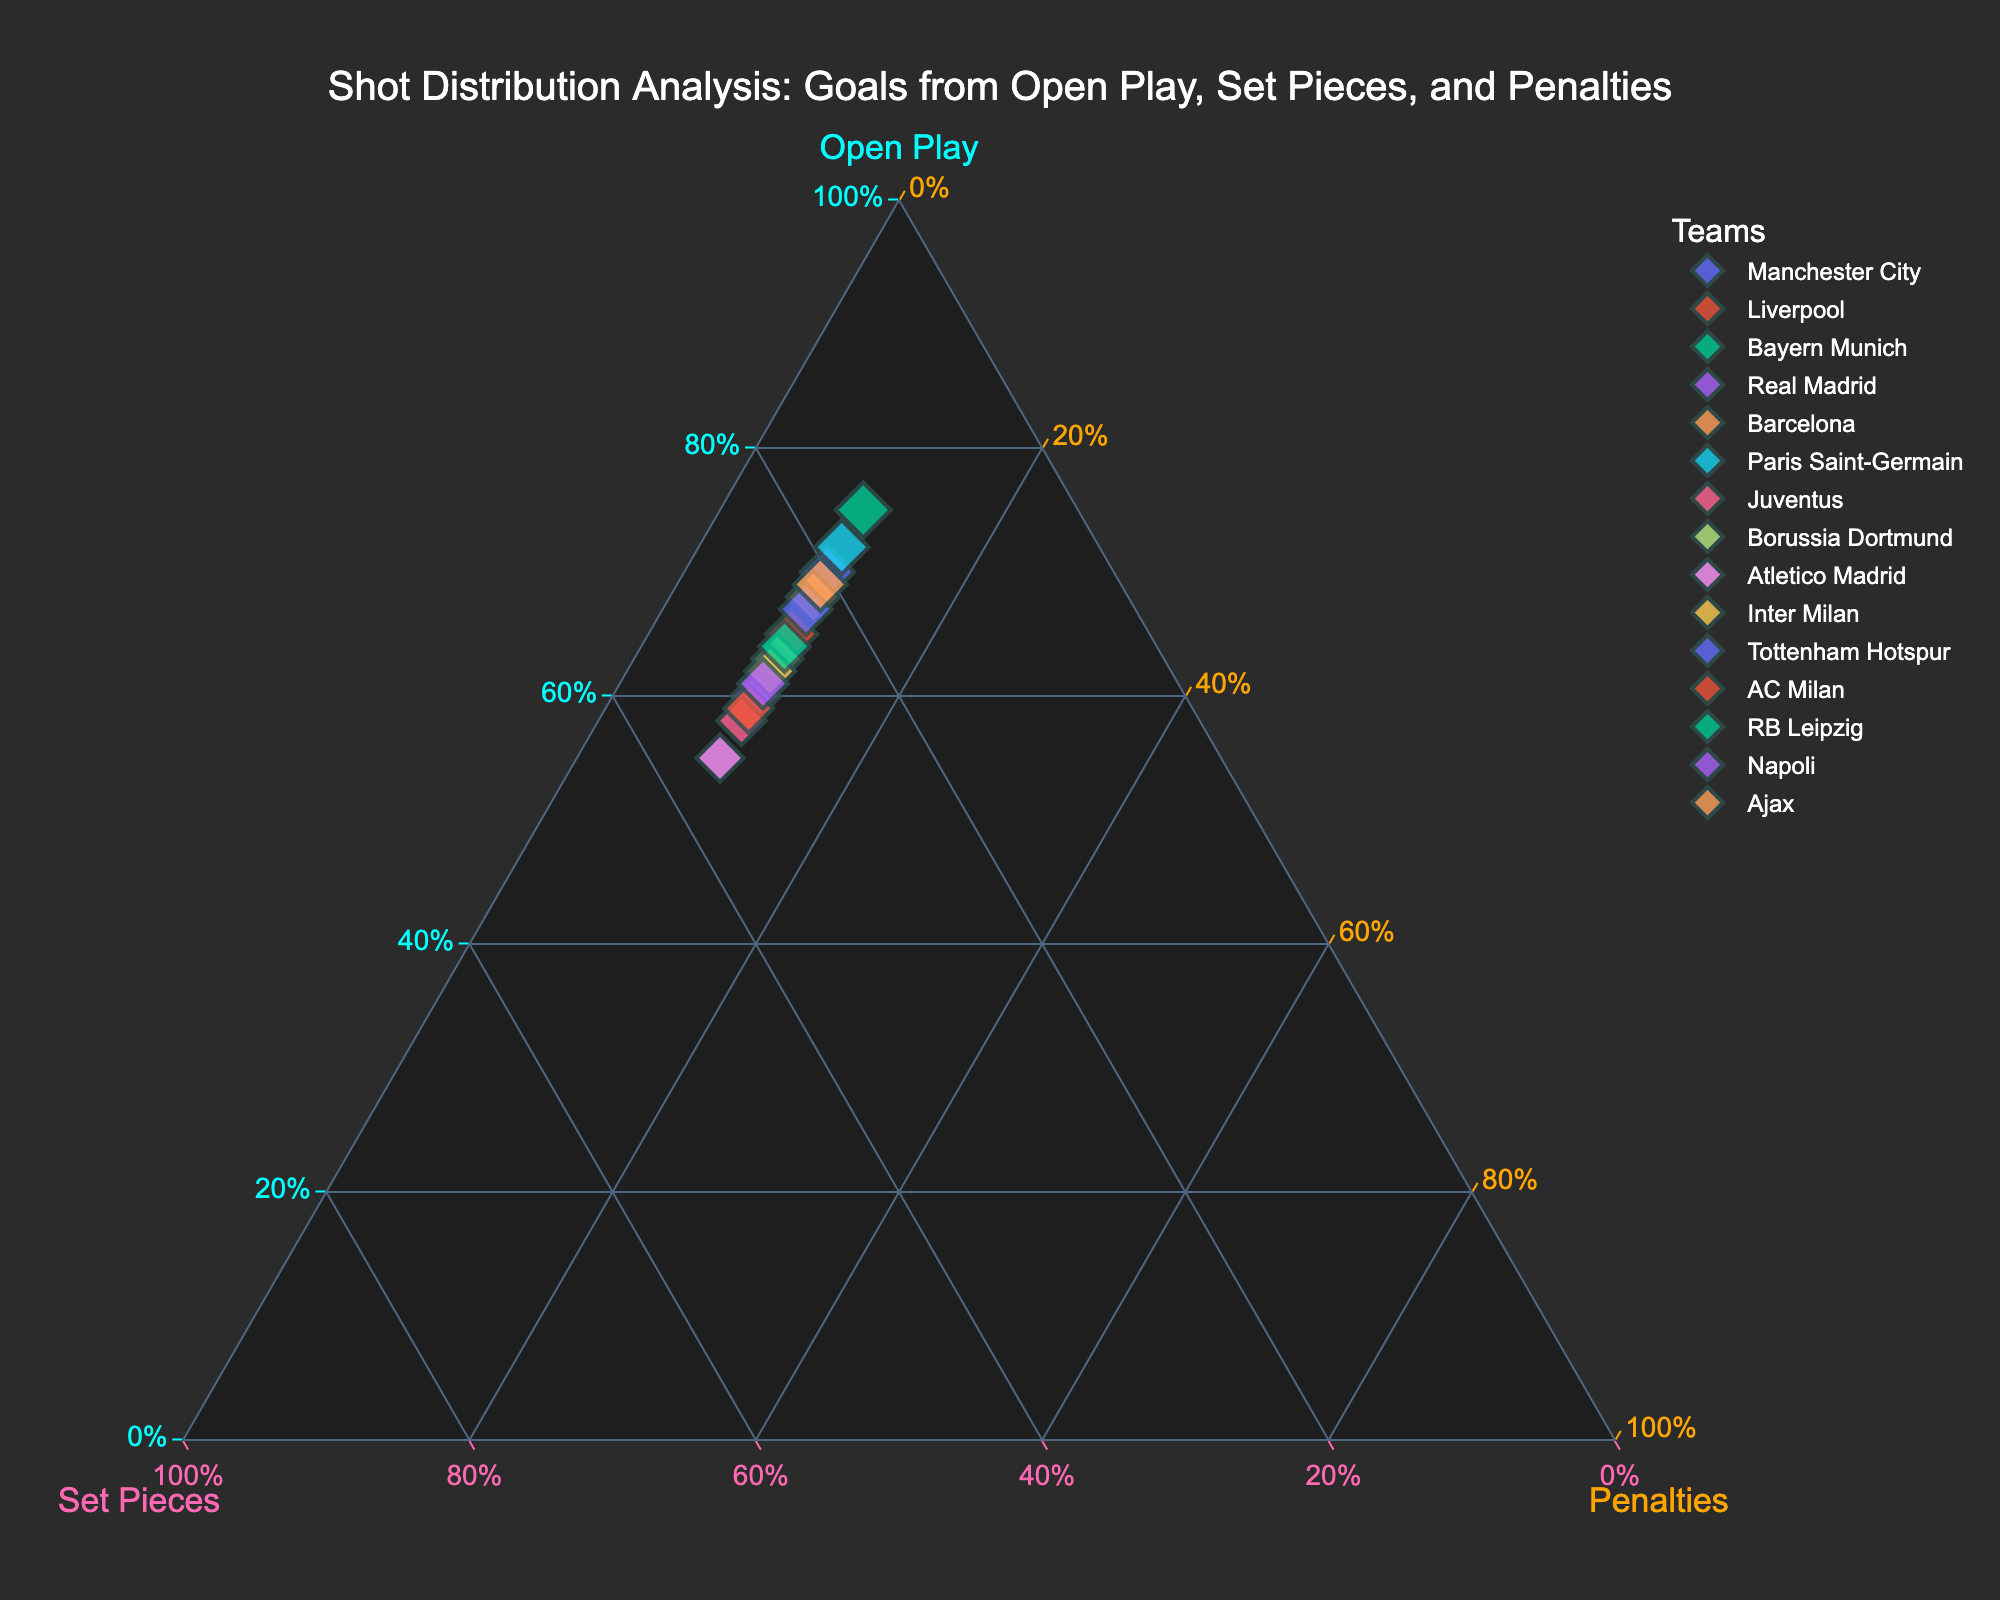How many teams are represented in the plot? To find the number of teams, count all unique data points. Each point represents a team. There are 15 unique teams presented.
Answer: 15 What is the title of the plot? The title is usually positioned at the top of the plot. In this case, it reads "Shot Distribution Analysis: Goals from Open Play, Set Pieces, and Penalties".
Answer: Shot Distribution Analysis: Goals from Open Play, Set Pieces, and Penalties Which team has the highest percentage of goals from open play? By looking at the apex representing "Open Play", identify the point closest to this axis. Bayern Munich is closest to the "Open Play" apex.
Answer: Bayern Munich Compare the goal distributions of Tottenham Hotspur and Barcelona. Who scores more from set pieces? Locate the points for both teams and compare their distances along the "Set Pieces" axis. Barcelona has a higher percentage on the "Set Pieces" axis compared to Tottenham.
Answer: Barcelona If we combine goals from open play and set pieces, which team has the highest percentage? Sum the percentages of "Open Play" and "Set Pieces" for each team. Bayern Munich has 75% from open play + 15% from set pieces = 90%, the highest combined percentage.
Answer: Bayern Munich How do most teams distribute their goals between open play, set pieces, and penalties? Observing the concentration of points, most teams have approximately 60-75% from open play, 15-35% from set pieces, and around 10% from penalties, forming a cluster in this range.
Answer: 60-75% open play, 15-35% set pieces, 10% penalties Which team favors set pieces the most? Check the "Set Pieces" axis for the point farthest along that axis. Atletico Madrid is farthest along the "Set Pieces" axis with 35%.
Answer: Atletico Madrid What is the average percentage of goals from open play for all teams? Add the open play percentages and divide by the number of teams: (70 + 65 + 75 + 60 + 68 + 72 + 58 + 63 + 55 + 62 + 67 + 59 + 64 + 61 + 69) / 15 = 973/15 = 64.87%
Answer: 64.87% Which teams have an equal percentage of goals from penalties? Locate points equally distanced from "Penalties" axis. Every team has 10% from penalties as represented in the dataset.
Answer: All teams 